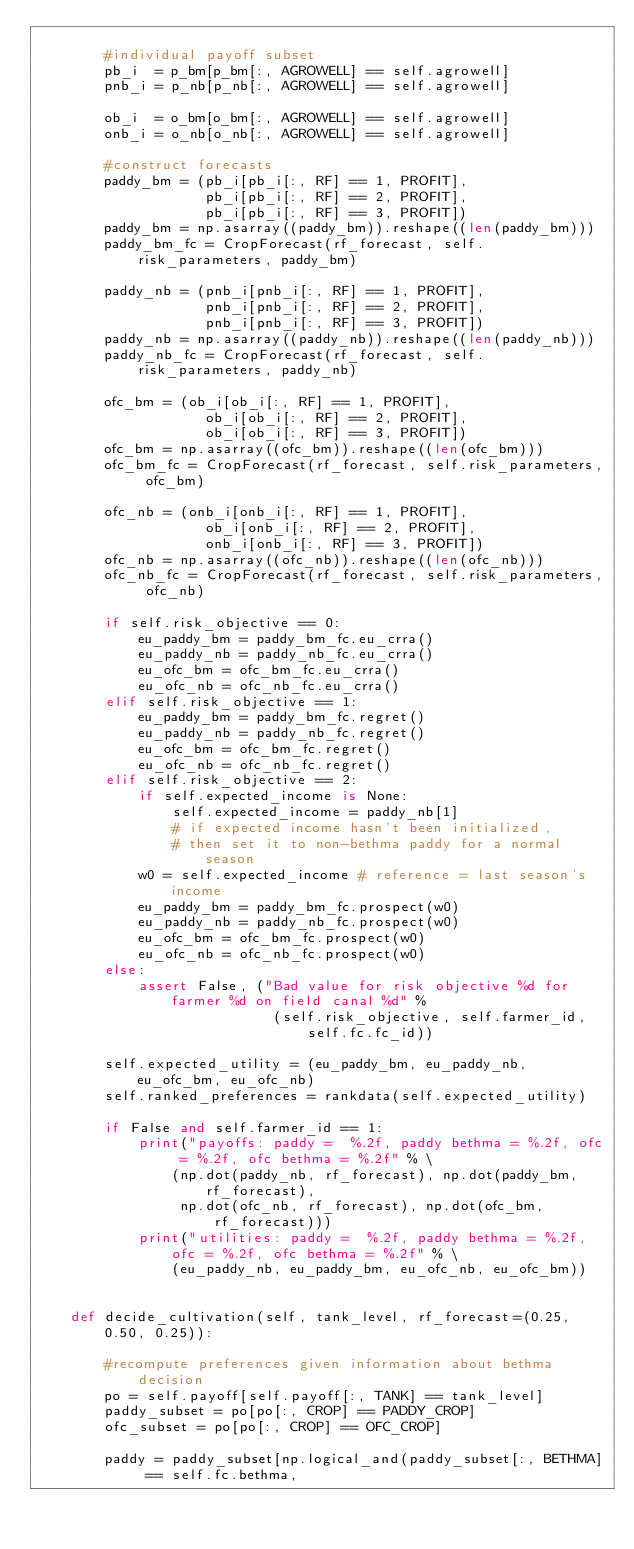<code> <loc_0><loc_0><loc_500><loc_500><_Python_>
        #individual payoff subset
        pb_i  = p_bm[p_bm[:, AGROWELL] == self.agrowell]
        pnb_i = p_nb[p_nb[:, AGROWELL] == self.agrowell]

        ob_i  = o_bm[o_bm[:, AGROWELL] == self.agrowell]
        onb_i = o_nb[o_nb[:, AGROWELL] == self.agrowell]

        #construct forecasts
        paddy_bm = (pb_i[pb_i[:, RF] == 1, PROFIT],
                    pb_i[pb_i[:, RF] == 2, PROFIT],
                    pb_i[pb_i[:, RF] == 3, PROFIT])
        paddy_bm = np.asarray((paddy_bm)).reshape((len(paddy_bm)))
        paddy_bm_fc = CropForecast(rf_forecast, self.risk_parameters, paddy_bm)

        paddy_nb = (pnb_i[pnb_i[:, RF] == 1, PROFIT],
                    pnb_i[pnb_i[:, RF] == 2, PROFIT],
                    pnb_i[pnb_i[:, RF] == 3, PROFIT])
        paddy_nb = np.asarray((paddy_nb)).reshape((len(paddy_nb)))
        paddy_nb_fc = CropForecast(rf_forecast, self.risk_parameters, paddy_nb)

        ofc_bm = (ob_i[ob_i[:, RF] == 1, PROFIT],
                    ob_i[ob_i[:, RF] == 2, PROFIT],
                    ob_i[ob_i[:, RF] == 3, PROFIT])
        ofc_bm = np.asarray((ofc_bm)).reshape((len(ofc_bm)))
        ofc_bm_fc = CropForecast(rf_forecast, self.risk_parameters, ofc_bm)

        ofc_nb = (onb_i[onb_i[:, RF] == 1, PROFIT],
                    ob_i[onb_i[:, RF] == 2, PROFIT],
                    onb_i[onb_i[:, RF] == 3, PROFIT])
        ofc_nb = np.asarray((ofc_nb)).reshape((len(ofc_nb)))
        ofc_nb_fc = CropForecast(rf_forecast, self.risk_parameters, ofc_nb)

        if self.risk_objective == 0:
            eu_paddy_bm = paddy_bm_fc.eu_crra()
            eu_paddy_nb = paddy_nb_fc.eu_crra()
            eu_ofc_bm = ofc_bm_fc.eu_crra()
            eu_ofc_nb = ofc_nb_fc.eu_crra()
        elif self.risk_objective == 1:
            eu_paddy_bm = paddy_bm_fc.regret()
            eu_paddy_nb = paddy_nb_fc.regret()
            eu_ofc_bm = ofc_bm_fc.regret()
            eu_ofc_nb = ofc_nb_fc.regret()
        elif self.risk_objective == 2:
            if self.expected_income is None:
                self.expected_income = paddy_nb[1]
                # if expected income hasn't been initialized,
                # then set it to non-bethma paddy for a normal season
            w0 = self.expected_income # reference = last season's income
            eu_paddy_bm = paddy_bm_fc.prospect(w0)
            eu_paddy_nb = paddy_nb_fc.prospect(w0)
            eu_ofc_bm = ofc_bm_fc.prospect(w0)
            eu_ofc_nb = ofc_nb_fc.prospect(w0)
        else:
            assert False, ("Bad value for risk objective %d for farmer %d on field canal %d" %
                            (self.risk_objective, self.farmer_id, self.fc.fc_id))

        self.expected_utility = (eu_paddy_bm, eu_paddy_nb, eu_ofc_bm, eu_ofc_nb)
        self.ranked_preferences = rankdata(self.expected_utility)

        if False and self.farmer_id == 1:
            print("payoffs: paddy =  %.2f, paddy bethma = %.2f, ofc = %.2f, ofc bethma = %.2f" % \
                (np.dot(paddy_nb, rf_forecast), np.dot(paddy_bm, rf_forecast),
                 np.dot(ofc_nb, rf_forecast), np.dot(ofc_bm, rf_forecast)))
            print("utilities: paddy =  %.2f, paddy bethma = %.2f, ofc = %.2f, ofc bethma = %.2f" % \
                (eu_paddy_nb, eu_paddy_bm, eu_ofc_nb, eu_ofc_bm))


    def decide_cultivation(self, tank_level, rf_forecast=(0.25, 0.50, 0.25)):

        #recompute preferences given information about bethma decision
        po = self.payoff[self.payoff[:, TANK] == tank_level]
        paddy_subset = po[po[:, CROP] == PADDY_CROP]
        ofc_subset = po[po[:, CROP] == OFC_CROP]

        paddy = paddy_subset[np.logical_and(paddy_subset[:, BETHMA] == self.fc.bethma,</code> 